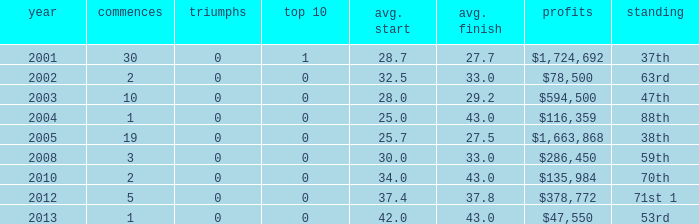What is the average top 10 score for 2 starts, winnings of $135,984 and an average finish more than 43? None. 